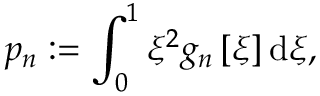Convert formula to latex. <formula><loc_0><loc_0><loc_500><loc_500>p _ { n } \colon = \int _ { 0 } ^ { 1 } \xi ^ { 2 } g _ { n } \left [ \xi \right ] d \xi ,</formula> 